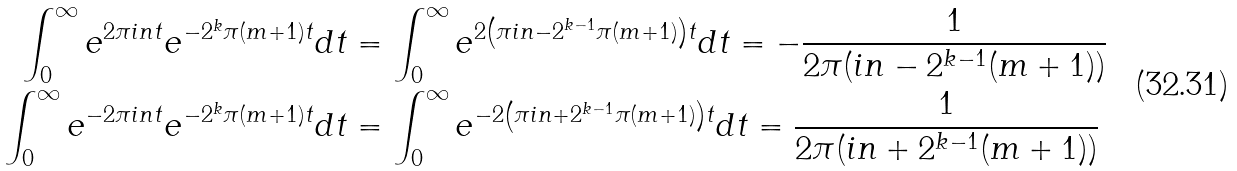Convert formula to latex. <formula><loc_0><loc_0><loc_500><loc_500>\int _ { 0 } ^ { \infty } e ^ { 2 \pi i n t } e ^ { - 2 ^ { k } \pi ( m + 1 ) t } d t & = \int _ { 0 } ^ { \infty } e ^ { 2 \left ( \pi i n - 2 ^ { k - 1 } \pi ( m + 1 ) \right ) t } d t = - \frac { 1 } { 2 \pi ( i n - 2 ^ { k - 1 } ( m + 1 ) ) } \\ \int _ { 0 } ^ { \infty } e ^ { - 2 \pi i n t } e ^ { - 2 ^ { k } \pi ( m + 1 ) t } d t & = \int _ { 0 } ^ { \infty } e ^ { - 2 \left ( \pi i n + 2 ^ { k - 1 } \pi ( m + 1 ) \right ) t } d t = \frac { 1 } { 2 \pi ( i n + 2 ^ { k - 1 } ( m + 1 ) ) }</formula> 